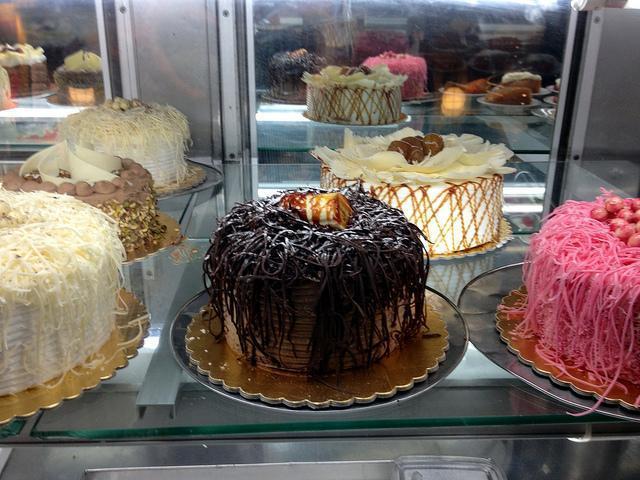How many cakes are pink?
Give a very brief answer. 1. How many cakes are there?
Give a very brief answer. 8. How many people have on red?
Give a very brief answer. 0. 